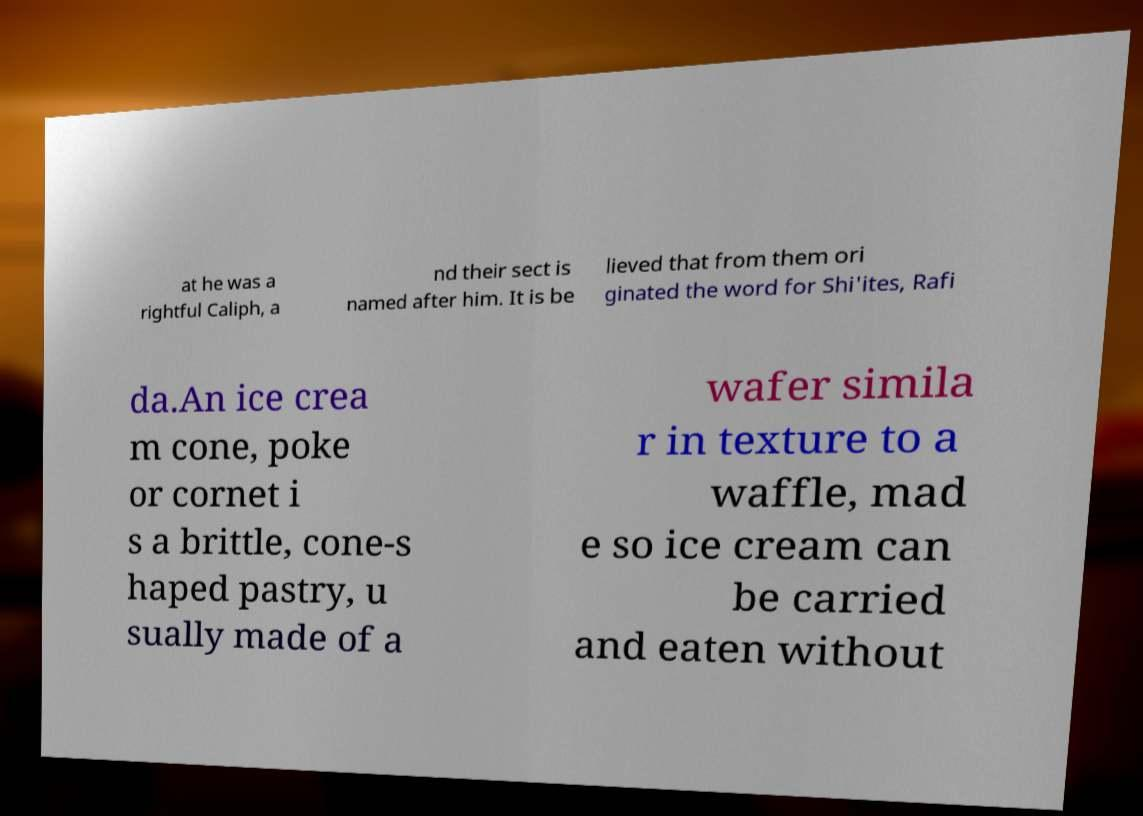For documentation purposes, I need the text within this image transcribed. Could you provide that? at he was a rightful Caliph, a nd their sect is named after him. It is be lieved that from them ori ginated the word for Shi'ites, Rafi da.An ice crea m cone, poke or cornet i s a brittle, cone-s haped pastry, u sually made of a wafer simila r in texture to a waffle, mad e so ice cream can be carried and eaten without 